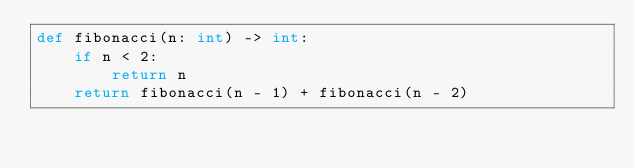Convert code to text. <code><loc_0><loc_0><loc_500><loc_500><_Python_>def fibonacci(n: int) -> int:
    if n < 2:
        return n
    return fibonacci(n - 1) + fibonacci(n - 2)
</code> 